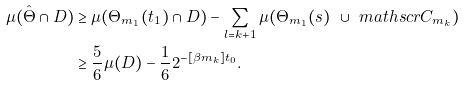<formula> <loc_0><loc_0><loc_500><loc_500>\mu ( \hat { \Theta } \cap D ) & \geq \mu ( \Theta _ { m _ { 1 } } ( t _ { 1 } ) \cap D ) - \sum _ { l = k + 1 } \mu ( \Theta _ { m _ { 1 } } ( s ) \ \cup \ m a t h s c r { C } _ { m _ { k } } ) \\ & \geq \frac { 5 } { 6 } \mu ( D ) - \frac { 1 } { 6 } 2 ^ { - [ \beta m _ { k } ] t _ { 0 } } .</formula> 